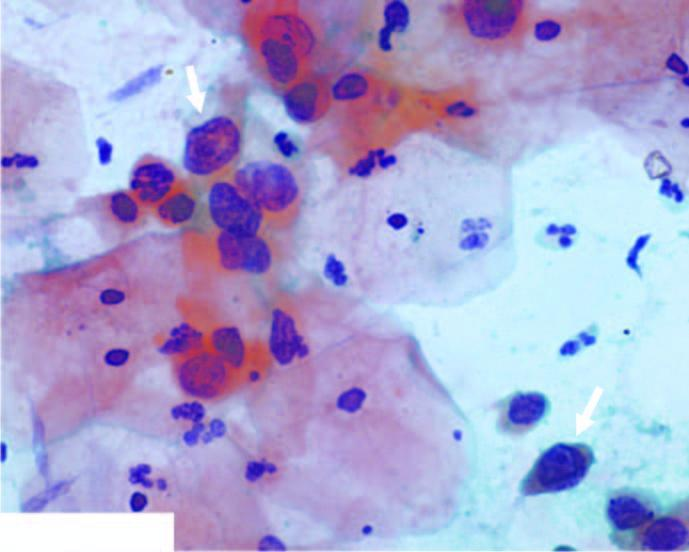do the squamous cells have scanty cytoplasm and markedly hyperchromatic nuclei having irregular nuclear outlines?
Answer the question using a single word or phrase. Yes 